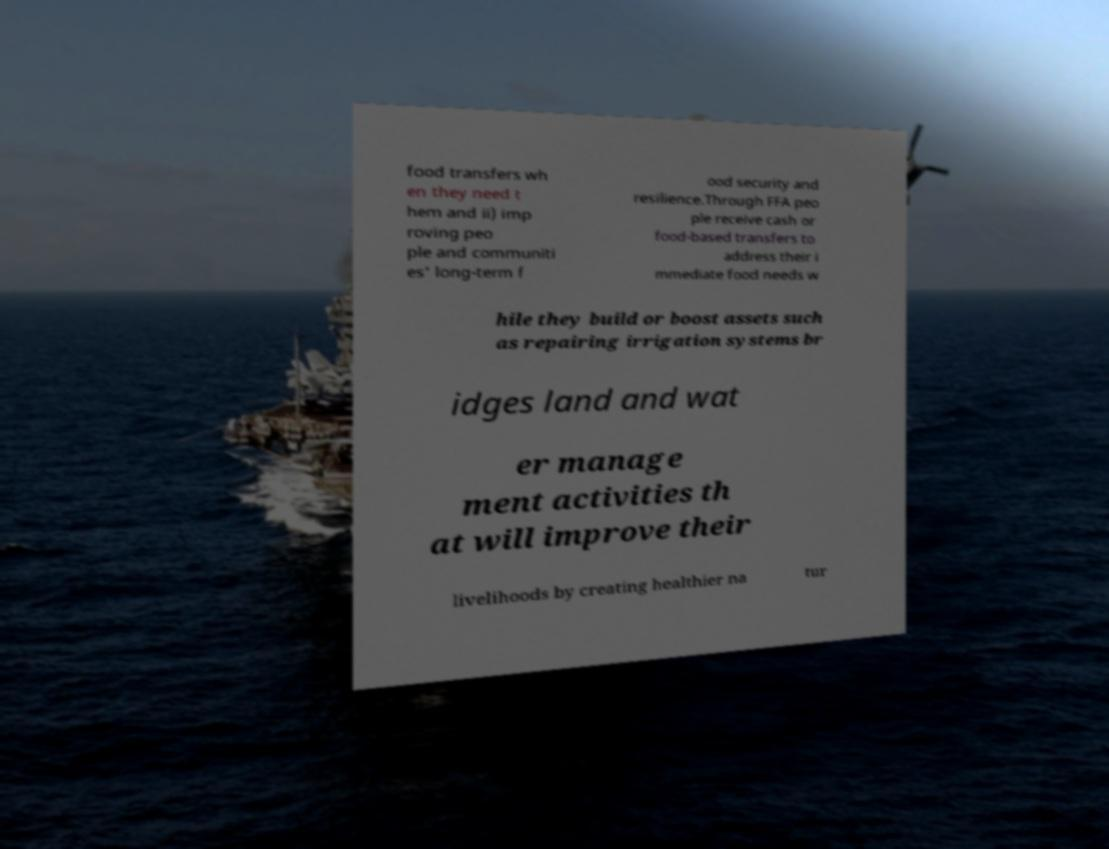Can you read and provide the text displayed in the image?This photo seems to have some interesting text. Can you extract and type it out for me? food transfers wh en they need t hem and ii) imp roving peo ple and communiti es' long-term f ood security and resilience.Through FFA peo ple receive cash or food-based transfers to address their i mmediate food needs w hile they build or boost assets such as repairing irrigation systems br idges land and wat er manage ment activities th at will improve their livelihoods by creating healthier na tur 